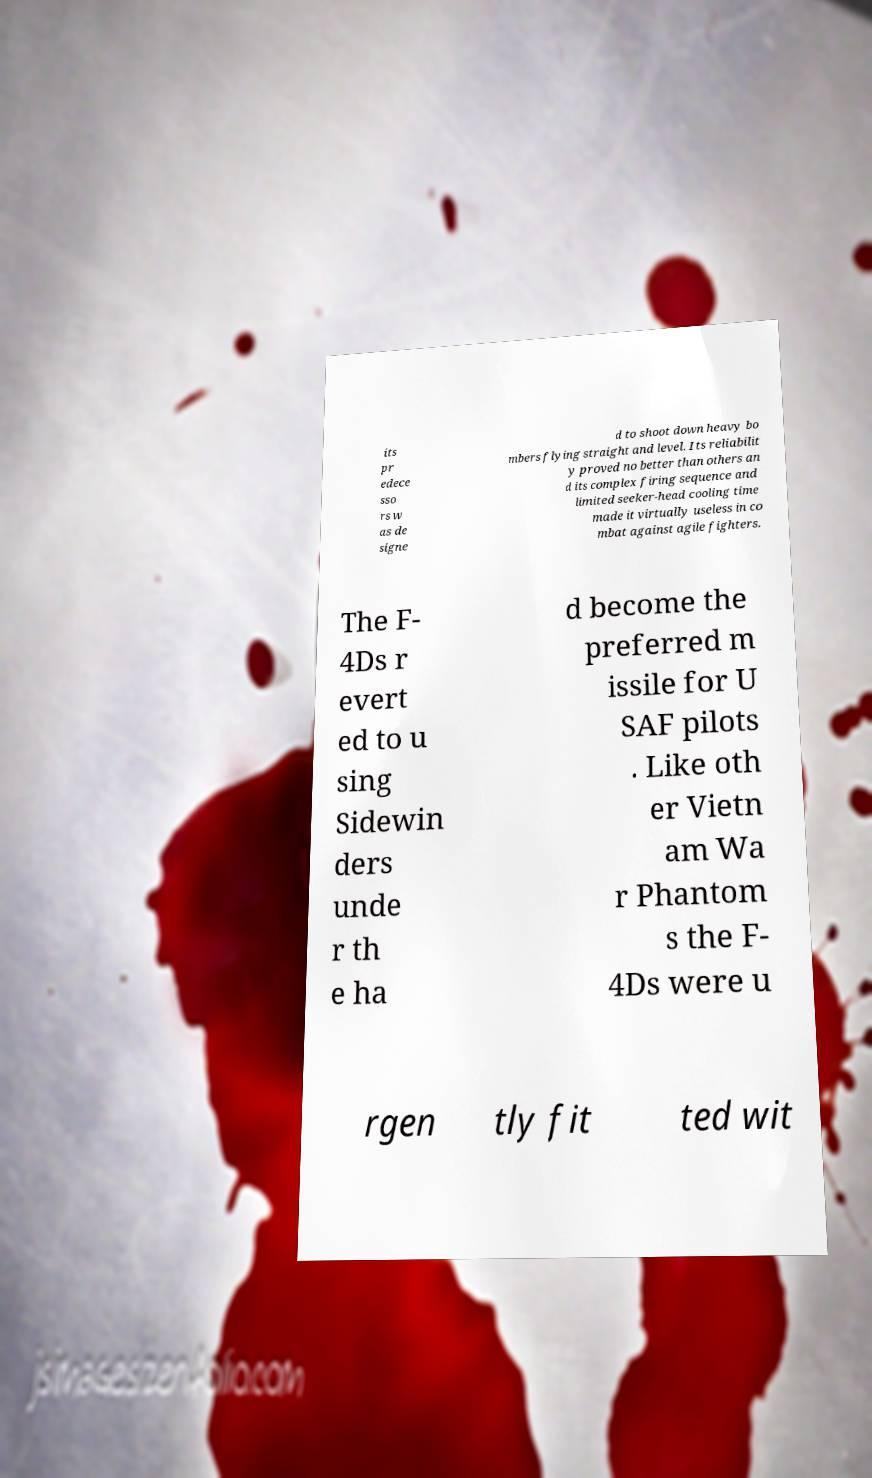There's text embedded in this image that I need extracted. Can you transcribe it verbatim? its pr edece sso rs w as de signe d to shoot down heavy bo mbers flying straight and level. Its reliabilit y proved no better than others an d its complex firing sequence and limited seeker-head cooling time made it virtually useless in co mbat against agile fighters. The F- 4Ds r evert ed to u sing Sidewin ders unde r th e ha d become the preferred m issile for U SAF pilots . Like oth er Vietn am Wa r Phantom s the F- 4Ds were u rgen tly fit ted wit 